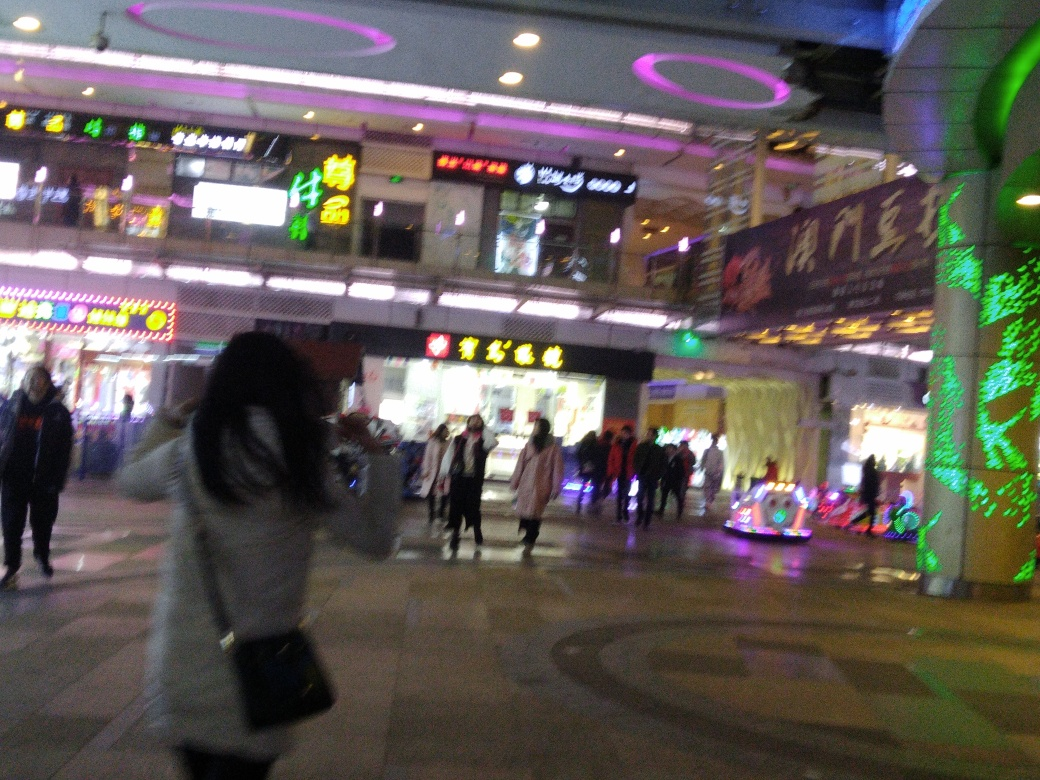What can you infer about the location from the signage in the background? The signage, brightly lit with characters that are characteristic of East Asian scripts, suggests that the location of the photograph is likely within an East Asian country. Without the ability to read the exact characters, one can only speculate on the precise location; however, the style of the characters and the density of the signage are indicative of a city center with a concentration of businesses and commercial establishments. Given the quality of the image, what might be a reason for the blurriness? The blurriness of the image can be attributed to a few possible factors: it may have been taken with a low shutter speed, which was not fast enough to freeze the motion of the pedestrians or stabilize the camera's own movement; alternatively, if the photographer was in motion, this would also contribute to the motion blur. Additionally, the image may appear grainy due to a high ISO setting, which is often used in low-light photography to compensate for the lack of light but can introduce noise and reduce image clarity. 